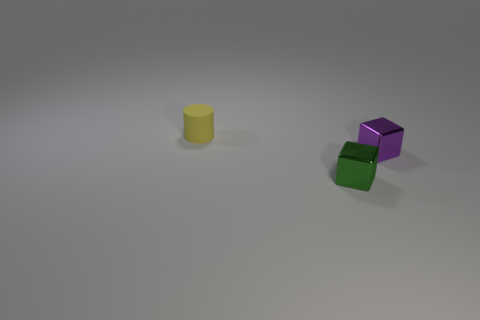Add 2 tiny metallic objects. How many objects exist? 5 Subtract all cylinders. How many objects are left? 2 Add 1 small yellow rubber things. How many small yellow rubber things are left? 2 Add 2 objects. How many objects exist? 5 Subtract 0 brown blocks. How many objects are left? 3 Subtract all shiny cubes. Subtract all tiny rubber cylinders. How many objects are left? 0 